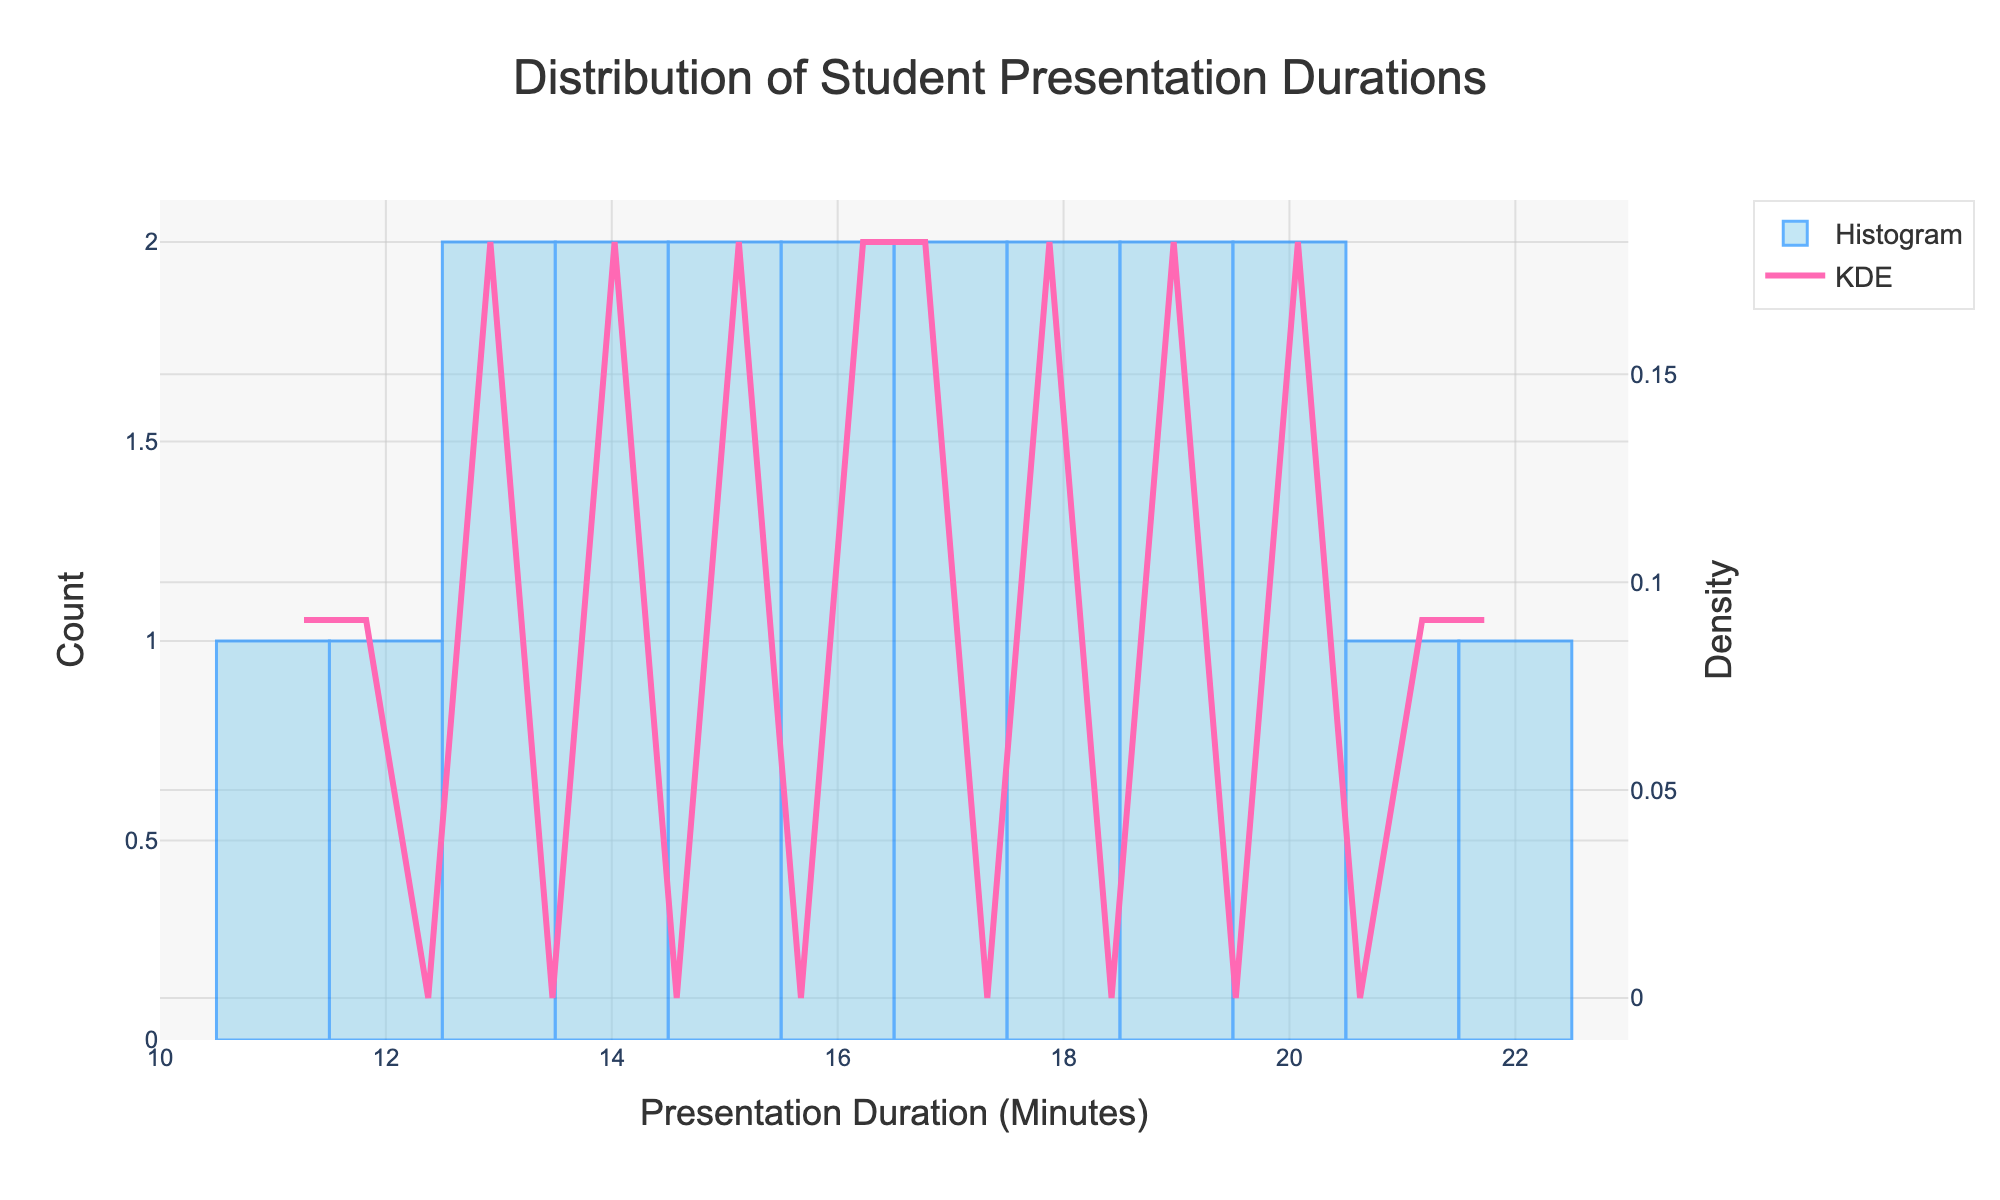What is the title of the figure? The title is generally found at the top of the figure. Here, it reads "Distribution of Student Presentation Durations".
Answer: Distribution of Student Presentation Durations What are the x-axis and y-axis titles for the histogram, respectively? The x-axis title is "Presentation Duration (Minutes)" and the y-axis title is "Count", as per the labels in the figure below the axes.
Answer: Presentation Duration (Minutes), Count What color represents the histogram bars? The histogram bars are colored in a shade of blue, specifically described as "light blue" with a name noted in the code as 'rgba(135, 206, 235, 0.7)'.
Answer: light blue What is the approximate range of presentation durations shown in the x-axis of the figure? By looking at the x-axis, the range of presentation durations spans from about 10 to 23 minutes.
Answer: 10 to 23 minutes How does the KDE (density curve) behave around the 15-minute mark? The density curve peaks around the 15-minute mark before descending, indicating a higher concentration of presentation durations around this time.
Answer: Peaks and then descends How many bins are used in the histogram? By analyzing the bin width and the range, there are approximately 15 bins used, visible in the histogram distribution.
Answer: 15 bins What is the most frequent presentation duration range observed in the histogram? The tallest histogram bar represents about 14 to 16 minutes, indicating this is the most frequent duration range.
Answer: 14 to 16 minutes What does the secondary y-axis represent and how is it labeled? The secondary y-axis, aligned with the KDE, represents 'Density' and is labeled accordingly.
Answer: Density Compare the density for presentation lengths of around 12 minutes and 20 minutes. The density for 12 minutes is lower compared to 20 minutes, shown by the KDE curve being higher at 20 minutes.
Answer: Lower at 12 minutes, higher at 20 minutes Based on the histogram and KDE, what would you say about the overall distribution of presentation durations? The distribution shows most students present around 14-16 minutes, tapering off towards the 10-minute and 22-minute marks, forming a slightly right-skewed distribution.
Answer: Right-skewed distribution around 14-16 minutes 